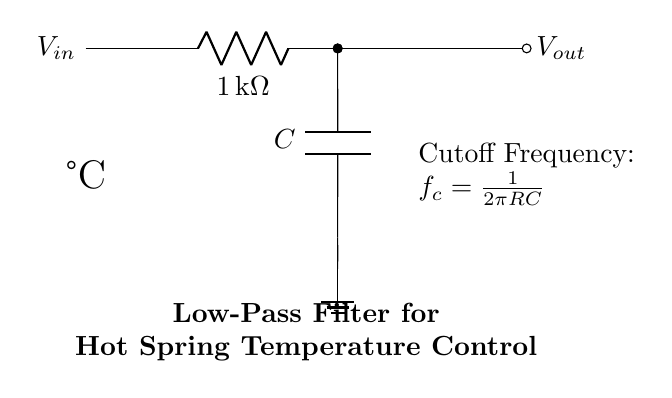What type of filter is shown in the circuit diagram? The diagram features a low-pass filter, indicated by the labeled components and the specific configuration designed to allow low-frequency signals to pass while attenuating high-frequency signals.
Answer: low-pass filter What is the resistance value of the resistor in the circuit? The resistor is labeled as one kilohm, which is specified in the diagram next to the resistor symbol.
Answer: one kilohm What is the role of the capacitor in this filter circuit? The capacitor, placed in parallel with the resistor, is responsible for storing charge and helps in defining the cutoff frequency, allowing the low-pass filter to function effectively by blocking high-frequency signals.
Answer: charge storage What is the cutoff frequency formula indicated in the circuit? The formula written in the circuit for the cutoff frequency is based on the resistor and capacitor values, presented as f_c = 1/(2πRC), where f_c, R, and C represent the cutoff frequency, resistance, and capacitance, respectively.
Answer: f_c = 1/(2πRC) How is the output voltage influenced by input voltage in this low-pass filter? The output voltage is determined by the input voltage and how much of the high-frequency noise is filtered out by the resistor and capacitor; specifically, lower frequencies appear more strongly at the output compared to higher frequencies.
Answer: attenuated What is the significance of the ground in this circuit? The ground provides a reference point for voltage measurements and ensures a common return path for current, which stabilizes the circuit operation and helps prevent float conditions.
Answer: reference point How is the circuit labeled to indicate its application? The circuit diagram is labeled with "Low-Pass Filter for Hot Spring Temperature Control," clearly associating the function of the filter with its specific application in temperature control systems for hot springs.
Answer: Hot Spring Temperature Control 